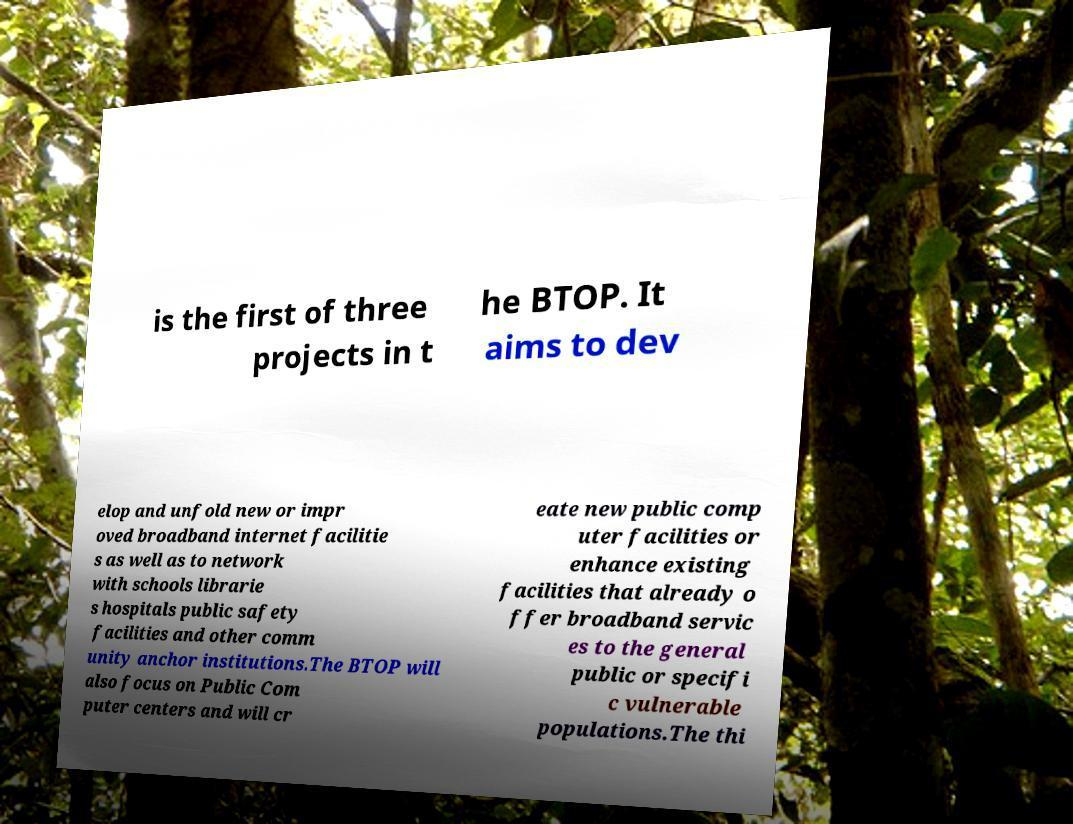For documentation purposes, I need the text within this image transcribed. Could you provide that? is the first of three projects in t he BTOP. It aims to dev elop and unfold new or impr oved broadband internet facilitie s as well as to network with schools librarie s hospitals public safety facilities and other comm unity anchor institutions.The BTOP will also focus on Public Com puter centers and will cr eate new public comp uter facilities or enhance existing facilities that already o ffer broadband servic es to the general public or specifi c vulnerable populations.The thi 